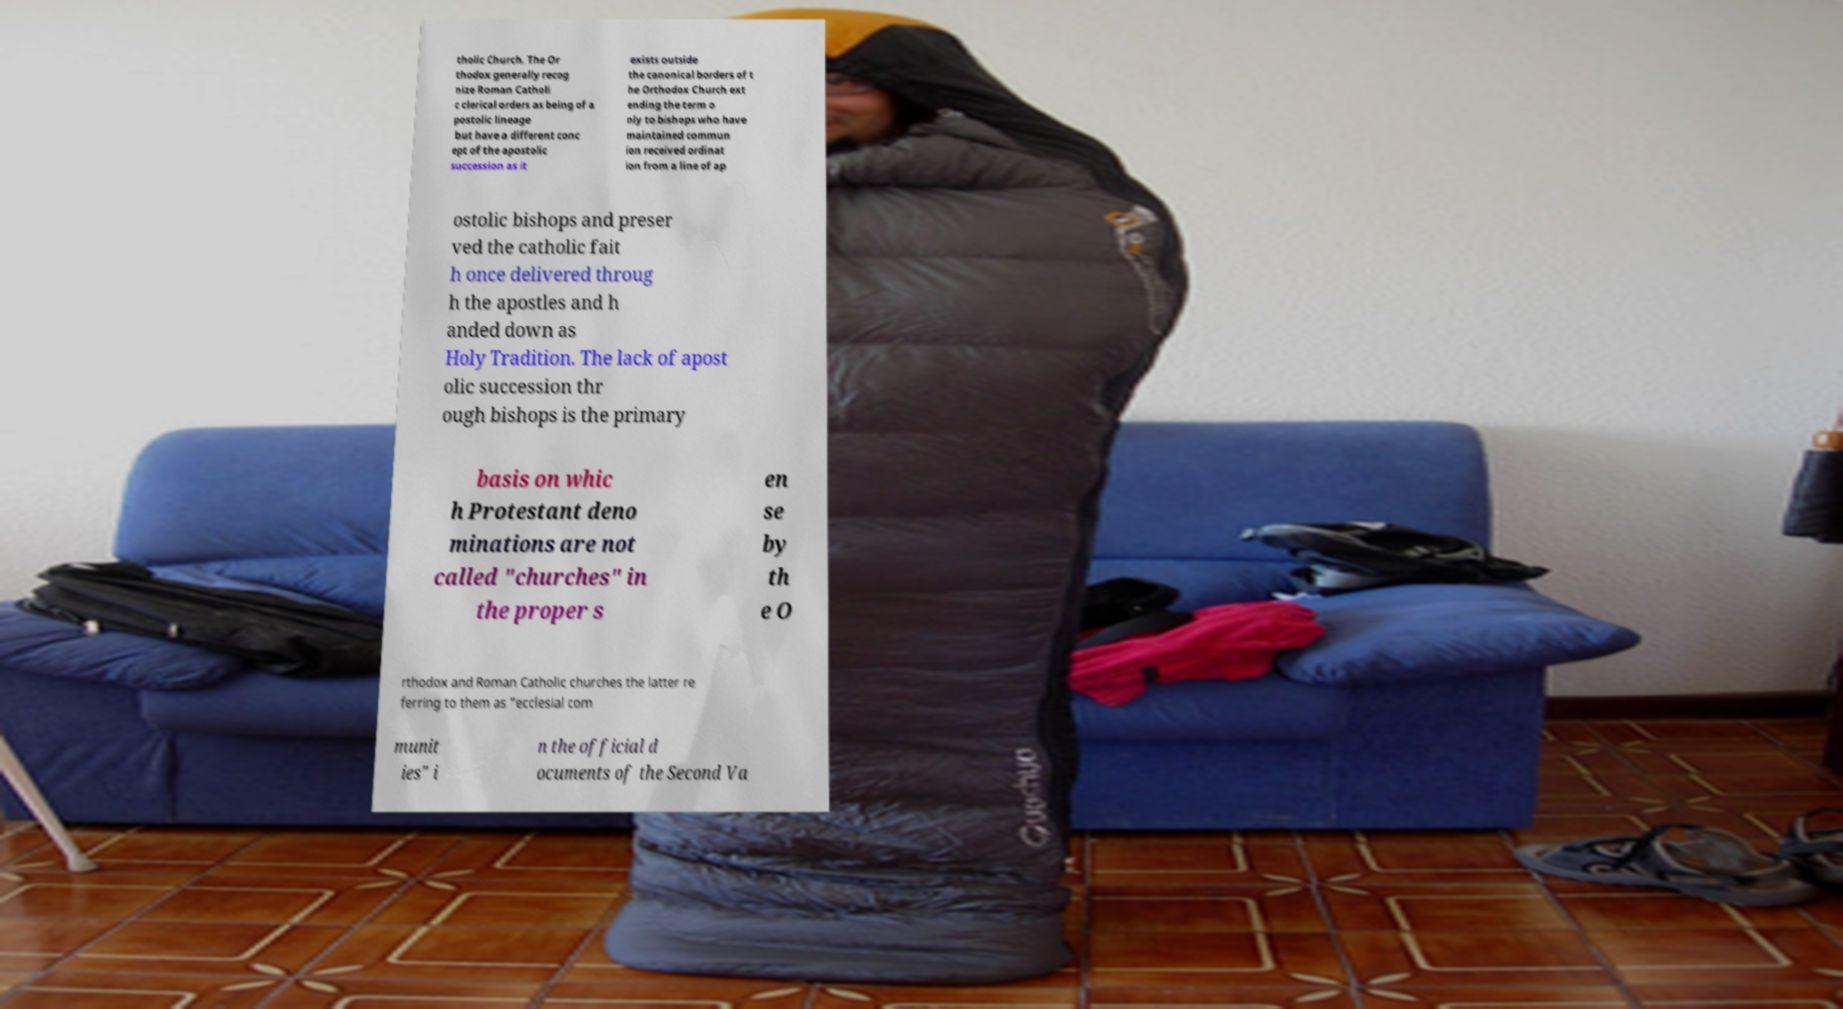For documentation purposes, I need the text within this image transcribed. Could you provide that? tholic Church. The Or thodox generally recog nize Roman Catholi c clerical orders as being of a postolic lineage but have a different conc ept of the apostolic succession as it exists outside the canonical borders of t he Orthodox Church ext ending the term o nly to bishops who have maintained commun ion received ordinat ion from a line of ap ostolic bishops and preser ved the catholic fait h once delivered throug h the apostles and h anded down as Holy Tradition. The lack of apost olic succession thr ough bishops is the primary basis on whic h Protestant deno minations are not called "churches" in the proper s en se by th e O rthodox and Roman Catholic churches the latter re ferring to them as "ecclesial com munit ies" i n the official d ocuments of the Second Va 